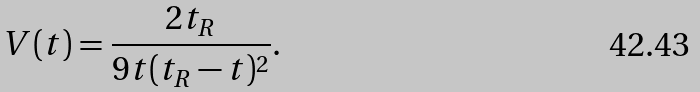<formula> <loc_0><loc_0><loc_500><loc_500>V ( t ) = \frac { 2 t _ { R } } { 9 t ( t _ { R } - t ) ^ { 2 } } .</formula> 